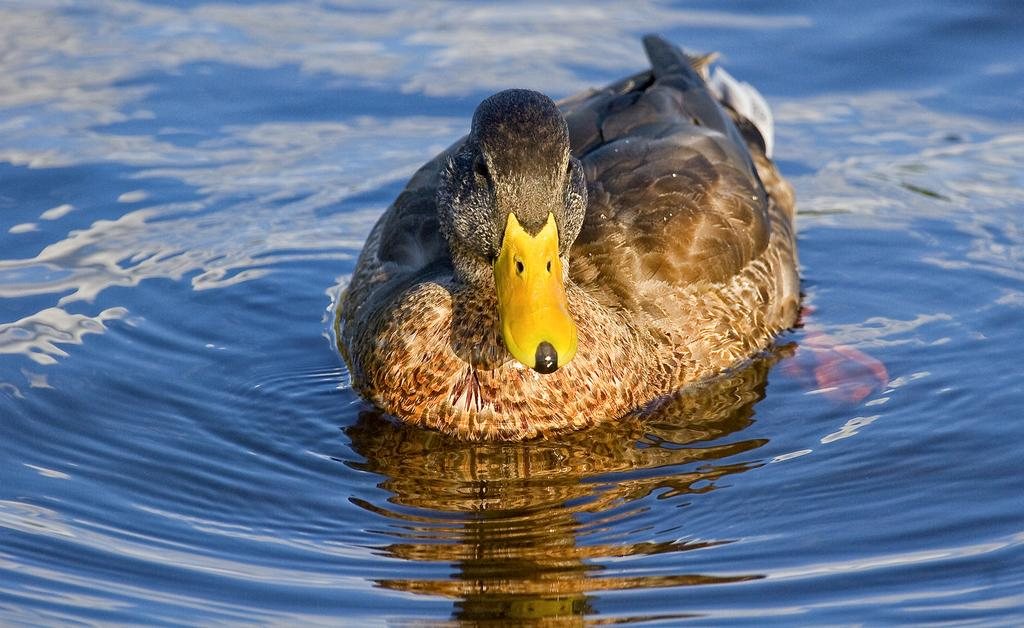What animal is present in the image? There is a duck in the image. Where is the duck located? The duck is in the water. What colors can be seen on the duck? The duck is black and brown in color. What type of tank is visible in the image? There is no tank present in the image; it features a duck in the water. How many sons does the duck have in the image? Ducks do not have sons; they have ducklings. However, there is no indication of ducklings or any other offspring in the image. 